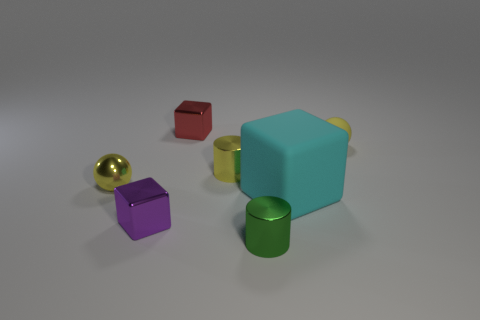Subtract all large cyan matte blocks. How many blocks are left? 2 Subtract all green cylinders. How many cylinders are left? 1 Subtract all cylinders. How many objects are left? 5 Subtract all cyan cylinders. How many purple spheres are left? 0 Subtract 0 blue balls. How many objects are left? 7 Subtract 1 cylinders. How many cylinders are left? 1 Subtract all red balls. Subtract all red cubes. How many balls are left? 2 Subtract all cyan rubber spheres. Subtract all metal things. How many objects are left? 2 Add 7 green things. How many green things are left? 8 Add 4 small yellow matte balls. How many small yellow matte balls exist? 5 